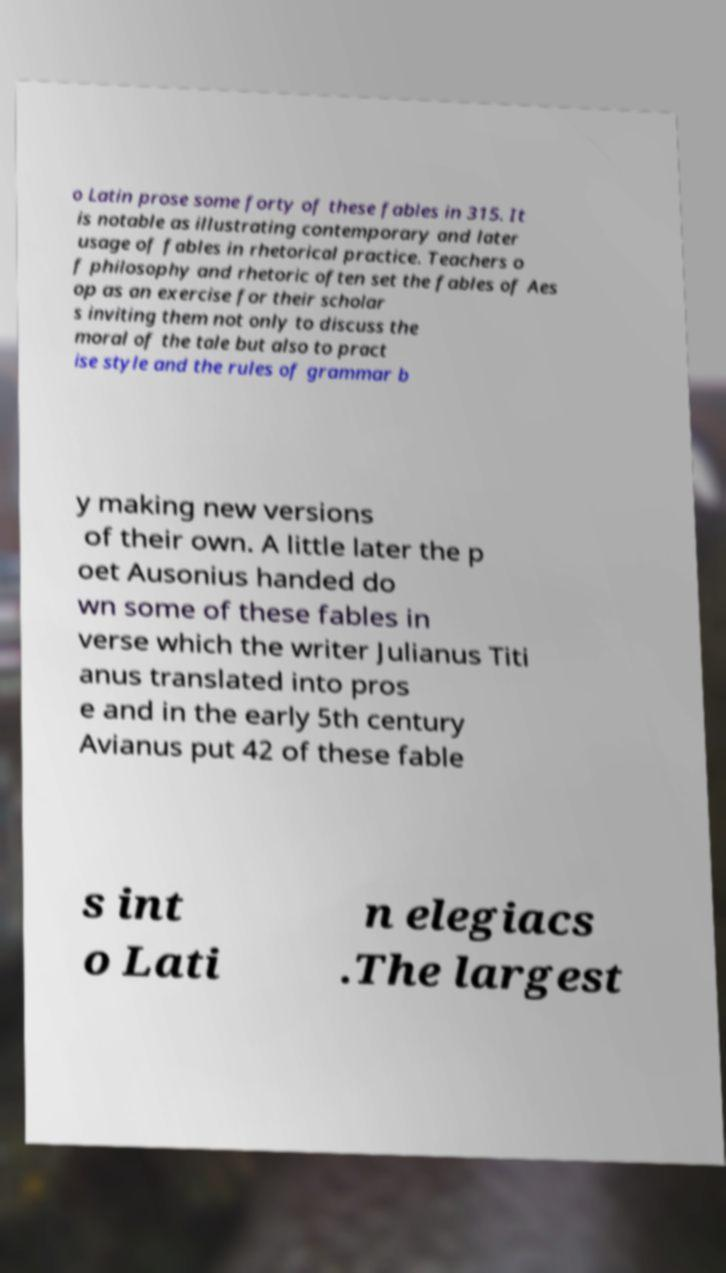Can you accurately transcribe the text from the provided image for me? o Latin prose some forty of these fables in 315. It is notable as illustrating contemporary and later usage of fables in rhetorical practice. Teachers o f philosophy and rhetoric often set the fables of Aes op as an exercise for their scholar s inviting them not only to discuss the moral of the tale but also to pract ise style and the rules of grammar b y making new versions of their own. A little later the p oet Ausonius handed do wn some of these fables in verse which the writer Julianus Titi anus translated into pros e and in the early 5th century Avianus put 42 of these fable s int o Lati n elegiacs .The largest 